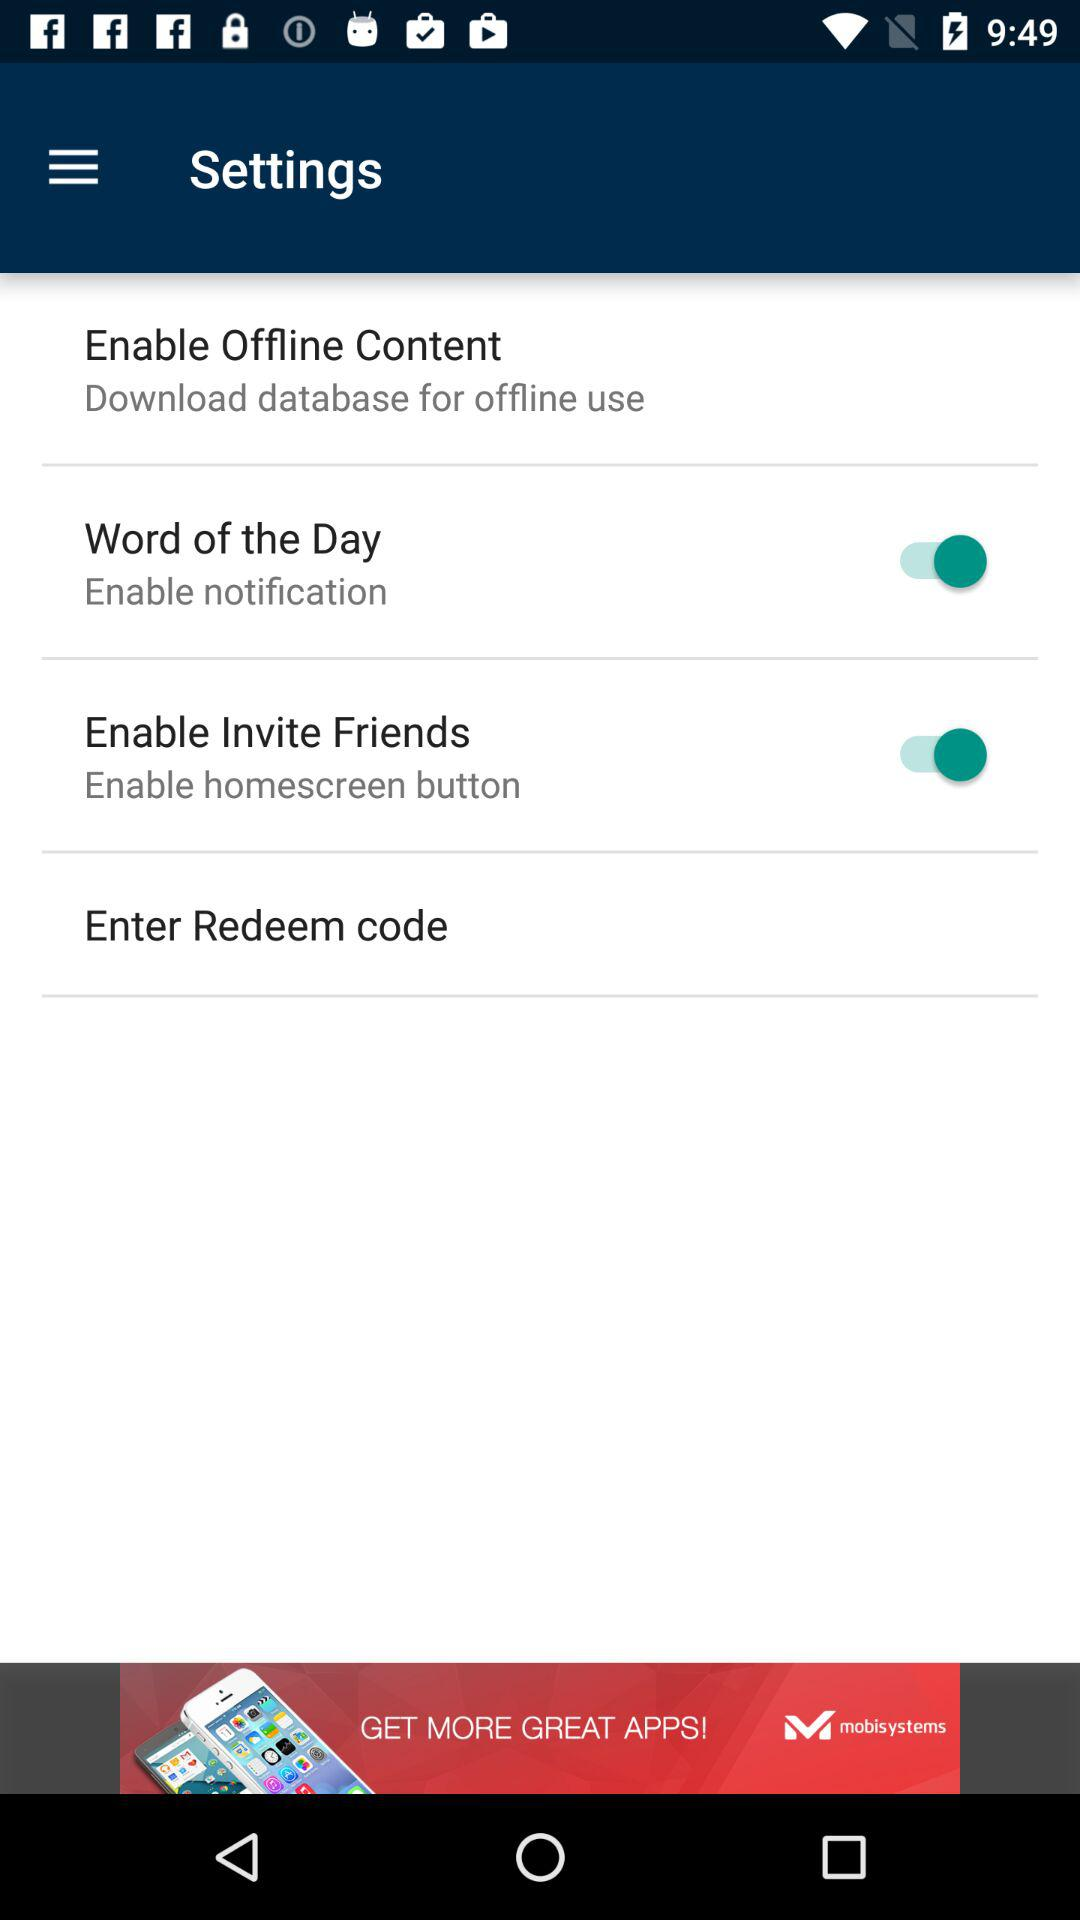How many notifications are there in "Settings"?
When the provided information is insufficient, respond with <no answer>. <no answer> 